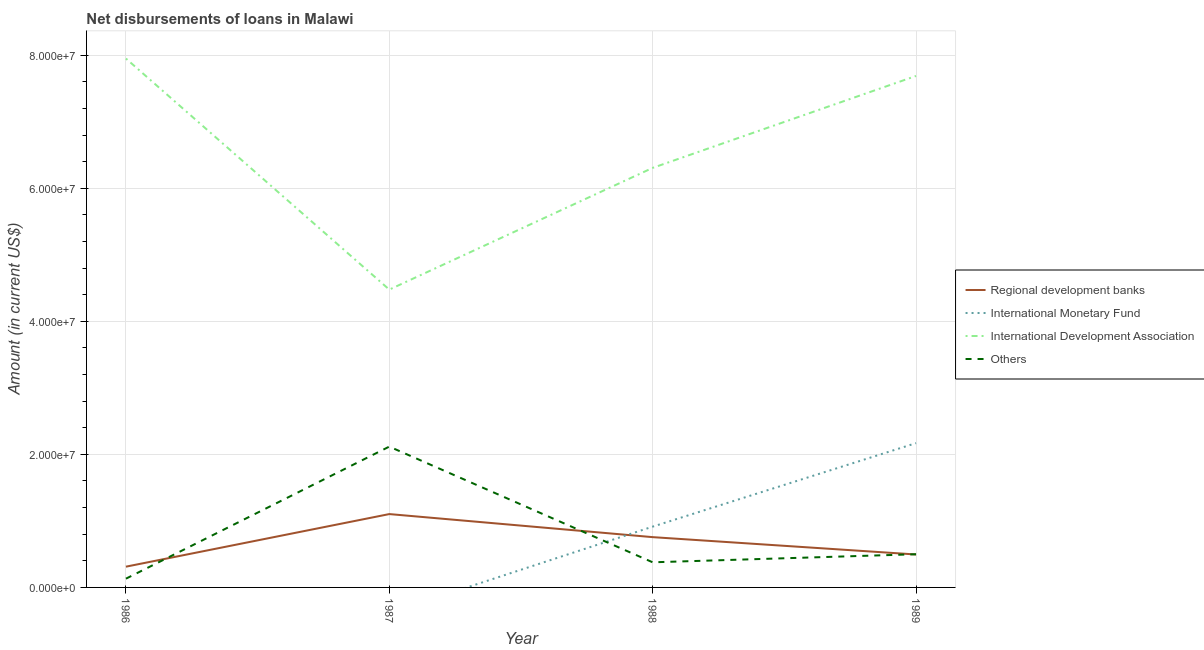Is the number of lines equal to the number of legend labels?
Your answer should be very brief. No. What is the amount of loan disimbursed by international development association in 1987?
Keep it short and to the point. 4.48e+07. Across all years, what is the maximum amount of loan disimbursed by international development association?
Ensure brevity in your answer.  7.95e+07. Across all years, what is the minimum amount of loan disimbursed by regional development banks?
Make the answer very short. 3.12e+06. In which year was the amount of loan disimbursed by international monetary fund maximum?
Offer a very short reply. 1989. What is the total amount of loan disimbursed by other organisations in the graph?
Your response must be concise. 3.13e+07. What is the difference between the amount of loan disimbursed by regional development banks in 1986 and that in 1989?
Your response must be concise. -1.83e+06. What is the difference between the amount of loan disimbursed by international monetary fund in 1989 and the amount of loan disimbursed by international development association in 1986?
Provide a short and direct response. -5.78e+07. What is the average amount of loan disimbursed by international monetary fund per year?
Ensure brevity in your answer.  7.71e+06. In the year 1988, what is the difference between the amount of loan disimbursed by other organisations and amount of loan disimbursed by international development association?
Give a very brief answer. -5.93e+07. What is the ratio of the amount of loan disimbursed by international development association in 1986 to that in 1989?
Give a very brief answer. 1.03. Is the amount of loan disimbursed by regional development banks in 1988 less than that in 1989?
Offer a terse response. No. What is the difference between the highest and the second highest amount of loan disimbursed by regional development banks?
Your response must be concise. 3.47e+06. What is the difference between the highest and the lowest amount of loan disimbursed by regional development banks?
Provide a succinct answer. 7.91e+06. In how many years, is the amount of loan disimbursed by international development association greater than the average amount of loan disimbursed by international development association taken over all years?
Your answer should be very brief. 2. Is it the case that in every year, the sum of the amount of loan disimbursed by regional development banks and amount of loan disimbursed by international monetary fund is greater than the sum of amount of loan disimbursed by other organisations and amount of loan disimbursed by international development association?
Offer a very short reply. No. Is it the case that in every year, the sum of the amount of loan disimbursed by regional development banks and amount of loan disimbursed by international monetary fund is greater than the amount of loan disimbursed by international development association?
Give a very brief answer. No. Is the amount of loan disimbursed by regional development banks strictly less than the amount of loan disimbursed by international development association over the years?
Make the answer very short. Yes. Does the graph contain grids?
Give a very brief answer. Yes. How many legend labels are there?
Your answer should be very brief. 4. What is the title of the graph?
Offer a terse response. Net disbursements of loans in Malawi. Does "United States" appear as one of the legend labels in the graph?
Offer a terse response. No. What is the label or title of the X-axis?
Give a very brief answer. Year. What is the label or title of the Y-axis?
Your answer should be compact. Amount (in current US$). What is the Amount (in current US$) in Regional development banks in 1986?
Your answer should be very brief. 3.12e+06. What is the Amount (in current US$) of International Monetary Fund in 1986?
Your answer should be very brief. 0. What is the Amount (in current US$) in International Development Association in 1986?
Provide a succinct answer. 7.95e+07. What is the Amount (in current US$) of Others in 1986?
Offer a terse response. 1.32e+06. What is the Amount (in current US$) in Regional development banks in 1987?
Keep it short and to the point. 1.10e+07. What is the Amount (in current US$) in International Development Association in 1987?
Ensure brevity in your answer.  4.48e+07. What is the Amount (in current US$) in Others in 1987?
Your answer should be compact. 2.12e+07. What is the Amount (in current US$) in Regional development banks in 1988?
Your answer should be very brief. 7.56e+06. What is the Amount (in current US$) in International Monetary Fund in 1988?
Give a very brief answer. 9.14e+06. What is the Amount (in current US$) in International Development Association in 1988?
Give a very brief answer. 6.31e+07. What is the Amount (in current US$) in Others in 1988?
Keep it short and to the point. 3.78e+06. What is the Amount (in current US$) of Regional development banks in 1989?
Provide a succinct answer. 4.95e+06. What is the Amount (in current US$) of International Monetary Fund in 1989?
Your answer should be very brief. 2.17e+07. What is the Amount (in current US$) of International Development Association in 1989?
Ensure brevity in your answer.  7.69e+07. What is the Amount (in current US$) in Others in 1989?
Your answer should be compact. 4.99e+06. Across all years, what is the maximum Amount (in current US$) in Regional development banks?
Offer a very short reply. 1.10e+07. Across all years, what is the maximum Amount (in current US$) in International Monetary Fund?
Your answer should be very brief. 2.17e+07. Across all years, what is the maximum Amount (in current US$) of International Development Association?
Your answer should be very brief. 7.95e+07. Across all years, what is the maximum Amount (in current US$) in Others?
Your answer should be very brief. 2.12e+07. Across all years, what is the minimum Amount (in current US$) in Regional development banks?
Offer a very short reply. 3.12e+06. Across all years, what is the minimum Amount (in current US$) in International Monetary Fund?
Your answer should be compact. 0. Across all years, what is the minimum Amount (in current US$) in International Development Association?
Your answer should be compact. 4.48e+07. Across all years, what is the minimum Amount (in current US$) of Others?
Keep it short and to the point. 1.32e+06. What is the total Amount (in current US$) of Regional development banks in the graph?
Keep it short and to the point. 2.67e+07. What is the total Amount (in current US$) in International Monetary Fund in the graph?
Your answer should be compact. 3.08e+07. What is the total Amount (in current US$) in International Development Association in the graph?
Your response must be concise. 2.64e+08. What is the total Amount (in current US$) of Others in the graph?
Offer a terse response. 3.13e+07. What is the difference between the Amount (in current US$) in Regional development banks in 1986 and that in 1987?
Your response must be concise. -7.91e+06. What is the difference between the Amount (in current US$) of International Development Association in 1986 and that in 1987?
Ensure brevity in your answer.  3.47e+07. What is the difference between the Amount (in current US$) of Others in 1986 and that in 1987?
Your answer should be very brief. -1.99e+07. What is the difference between the Amount (in current US$) of Regional development banks in 1986 and that in 1988?
Keep it short and to the point. -4.44e+06. What is the difference between the Amount (in current US$) in International Development Association in 1986 and that in 1988?
Give a very brief answer. 1.64e+07. What is the difference between the Amount (in current US$) of Others in 1986 and that in 1988?
Your answer should be very brief. -2.46e+06. What is the difference between the Amount (in current US$) of Regional development banks in 1986 and that in 1989?
Make the answer very short. -1.83e+06. What is the difference between the Amount (in current US$) of International Development Association in 1986 and that in 1989?
Your response must be concise. 2.62e+06. What is the difference between the Amount (in current US$) in Others in 1986 and that in 1989?
Provide a short and direct response. -3.67e+06. What is the difference between the Amount (in current US$) of Regional development banks in 1987 and that in 1988?
Give a very brief answer. 3.47e+06. What is the difference between the Amount (in current US$) of International Development Association in 1987 and that in 1988?
Your answer should be very brief. -1.83e+07. What is the difference between the Amount (in current US$) in Others in 1987 and that in 1988?
Give a very brief answer. 1.74e+07. What is the difference between the Amount (in current US$) in Regional development banks in 1987 and that in 1989?
Offer a terse response. 6.08e+06. What is the difference between the Amount (in current US$) in International Development Association in 1987 and that in 1989?
Your answer should be compact. -3.21e+07. What is the difference between the Amount (in current US$) in Others in 1987 and that in 1989?
Provide a short and direct response. 1.62e+07. What is the difference between the Amount (in current US$) of Regional development banks in 1988 and that in 1989?
Offer a terse response. 2.61e+06. What is the difference between the Amount (in current US$) of International Monetary Fund in 1988 and that in 1989?
Your answer should be very brief. -1.26e+07. What is the difference between the Amount (in current US$) in International Development Association in 1988 and that in 1989?
Offer a very short reply. -1.38e+07. What is the difference between the Amount (in current US$) of Others in 1988 and that in 1989?
Offer a very short reply. -1.21e+06. What is the difference between the Amount (in current US$) of Regional development banks in 1986 and the Amount (in current US$) of International Development Association in 1987?
Offer a terse response. -4.17e+07. What is the difference between the Amount (in current US$) in Regional development banks in 1986 and the Amount (in current US$) in Others in 1987?
Keep it short and to the point. -1.80e+07. What is the difference between the Amount (in current US$) of International Development Association in 1986 and the Amount (in current US$) of Others in 1987?
Your response must be concise. 5.83e+07. What is the difference between the Amount (in current US$) of Regional development banks in 1986 and the Amount (in current US$) of International Monetary Fund in 1988?
Your response must be concise. -6.02e+06. What is the difference between the Amount (in current US$) in Regional development banks in 1986 and the Amount (in current US$) in International Development Association in 1988?
Your answer should be very brief. -6.00e+07. What is the difference between the Amount (in current US$) in Regional development banks in 1986 and the Amount (in current US$) in Others in 1988?
Offer a very short reply. -6.57e+05. What is the difference between the Amount (in current US$) in International Development Association in 1986 and the Amount (in current US$) in Others in 1988?
Ensure brevity in your answer.  7.57e+07. What is the difference between the Amount (in current US$) of Regional development banks in 1986 and the Amount (in current US$) of International Monetary Fund in 1989?
Your response must be concise. -1.86e+07. What is the difference between the Amount (in current US$) of Regional development banks in 1986 and the Amount (in current US$) of International Development Association in 1989?
Your response must be concise. -7.38e+07. What is the difference between the Amount (in current US$) in Regional development banks in 1986 and the Amount (in current US$) in Others in 1989?
Ensure brevity in your answer.  -1.87e+06. What is the difference between the Amount (in current US$) of International Development Association in 1986 and the Amount (in current US$) of Others in 1989?
Give a very brief answer. 7.45e+07. What is the difference between the Amount (in current US$) of Regional development banks in 1987 and the Amount (in current US$) of International Monetary Fund in 1988?
Make the answer very short. 1.89e+06. What is the difference between the Amount (in current US$) in Regional development banks in 1987 and the Amount (in current US$) in International Development Association in 1988?
Provide a short and direct response. -5.20e+07. What is the difference between the Amount (in current US$) in Regional development banks in 1987 and the Amount (in current US$) in Others in 1988?
Ensure brevity in your answer.  7.25e+06. What is the difference between the Amount (in current US$) of International Development Association in 1987 and the Amount (in current US$) of Others in 1988?
Keep it short and to the point. 4.10e+07. What is the difference between the Amount (in current US$) in Regional development banks in 1987 and the Amount (in current US$) in International Monetary Fund in 1989?
Give a very brief answer. -1.07e+07. What is the difference between the Amount (in current US$) of Regional development banks in 1987 and the Amount (in current US$) of International Development Association in 1989?
Your answer should be compact. -6.59e+07. What is the difference between the Amount (in current US$) in Regional development banks in 1987 and the Amount (in current US$) in Others in 1989?
Offer a terse response. 6.04e+06. What is the difference between the Amount (in current US$) of International Development Association in 1987 and the Amount (in current US$) of Others in 1989?
Provide a succinct answer. 3.98e+07. What is the difference between the Amount (in current US$) in Regional development banks in 1988 and the Amount (in current US$) in International Monetary Fund in 1989?
Your response must be concise. -1.41e+07. What is the difference between the Amount (in current US$) in Regional development banks in 1988 and the Amount (in current US$) in International Development Association in 1989?
Give a very brief answer. -6.93e+07. What is the difference between the Amount (in current US$) of Regional development banks in 1988 and the Amount (in current US$) of Others in 1989?
Offer a terse response. 2.57e+06. What is the difference between the Amount (in current US$) in International Monetary Fund in 1988 and the Amount (in current US$) in International Development Association in 1989?
Your answer should be compact. -6.78e+07. What is the difference between the Amount (in current US$) of International Monetary Fund in 1988 and the Amount (in current US$) of Others in 1989?
Make the answer very short. 4.15e+06. What is the difference between the Amount (in current US$) of International Development Association in 1988 and the Amount (in current US$) of Others in 1989?
Your answer should be compact. 5.81e+07. What is the average Amount (in current US$) of Regional development banks per year?
Provide a short and direct response. 6.66e+06. What is the average Amount (in current US$) of International Monetary Fund per year?
Provide a succinct answer. 7.71e+06. What is the average Amount (in current US$) in International Development Association per year?
Your answer should be very brief. 6.61e+07. What is the average Amount (in current US$) in Others per year?
Your answer should be compact. 7.81e+06. In the year 1986, what is the difference between the Amount (in current US$) of Regional development banks and Amount (in current US$) of International Development Association?
Your answer should be very brief. -7.64e+07. In the year 1986, what is the difference between the Amount (in current US$) in Regional development banks and Amount (in current US$) in Others?
Keep it short and to the point. 1.80e+06. In the year 1986, what is the difference between the Amount (in current US$) in International Development Association and Amount (in current US$) in Others?
Give a very brief answer. 7.82e+07. In the year 1987, what is the difference between the Amount (in current US$) of Regional development banks and Amount (in current US$) of International Development Association?
Your response must be concise. -3.37e+07. In the year 1987, what is the difference between the Amount (in current US$) in Regional development banks and Amount (in current US$) in Others?
Ensure brevity in your answer.  -1.01e+07. In the year 1987, what is the difference between the Amount (in current US$) of International Development Association and Amount (in current US$) of Others?
Provide a short and direct response. 2.36e+07. In the year 1988, what is the difference between the Amount (in current US$) in Regional development banks and Amount (in current US$) in International Monetary Fund?
Your response must be concise. -1.58e+06. In the year 1988, what is the difference between the Amount (in current US$) of Regional development banks and Amount (in current US$) of International Development Association?
Give a very brief answer. -5.55e+07. In the year 1988, what is the difference between the Amount (in current US$) of Regional development banks and Amount (in current US$) of Others?
Provide a succinct answer. 3.78e+06. In the year 1988, what is the difference between the Amount (in current US$) in International Monetary Fund and Amount (in current US$) in International Development Association?
Provide a short and direct response. -5.39e+07. In the year 1988, what is the difference between the Amount (in current US$) of International Monetary Fund and Amount (in current US$) of Others?
Offer a very short reply. 5.36e+06. In the year 1988, what is the difference between the Amount (in current US$) of International Development Association and Amount (in current US$) of Others?
Offer a very short reply. 5.93e+07. In the year 1989, what is the difference between the Amount (in current US$) in Regional development banks and Amount (in current US$) in International Monetary Fund?
Ensure brevity in your answer.  -1.67e+07. In the year 1989, what is the difference between the Amount (in current US$) in Regional development banks and Amount (in current US$) in International Development Association?
Ensure brevity in your answer.  -7.19e+07. In the year 1989, what is the difference between the Amount (in current US$) in Regional development banks and Amount (in current US$) in Others?
Your response must be concise. -4.00e+04. In the year 1989, what is the difference between the Amount (in current US$) of International Monetary Fund and Amount (in current US$) of International Development Association?
Provide a short and direct response. -5.52e+07. In the year 1989, what is the difference between the Amount (in current US$) of International Monetary Fund and Amount (in current US$) of Others?
Provide a short and direct response. 1.67e+07. In the year 1989, what is the difference between the Amount (in current US$) in International Development Association and Amount (in current US$) in Others?
Offer a very short reply. 7.19e+07. What is the ratio of the Amount (in current US$) in Regional development banks in 1986 to that in 1987?
Offer a very short reply. 0.28. What is the ratio of the Amount (in current US$) in International Development Association in 1986 to that in 1987?
Provide a succinct answer. 1.78. What is the ratio of the Amount (in current US$) of Others in 1986 to that in 1987?
Give a very brief answer. 0.06. What is the ratio of the Amount (in current US$) in Regional development banks in 1986 to that in 1988?
Provide a short and direct response. 0.41. What is the ratio of the Amount (in current US$) in International Development Association in 1986 to that in 1988?
Offer a terse response. 1.26. What is the ratio of the Amount (in current US$) in Others in 1986 to that in 1988?
Provide a succinct answer. 0.35. What is the ratio of the Amount (in current US$) in Regional development banks in 1986 to that in 1989?
Provide a short and direct response. 0.63. What is the ratio of the Amount (in current US$) of International Development Association in 1986 to that in 1989?
Provide a succinct answer. 1.03. What is the ratio of the Amount (in current US$) of Others in 1986 to that in 1989?
Offer a very short reply. 0.26. What is the ratio of the Amount (in current US$) of Regional development banks in 1987 to that in 1988?
Your answer should be very brief. 1.46. What is the ratio of the Amount (in current US$) of International Development Association in 1987 to that in 1988?
Make the answer very short. 0.71. What is the ratio of the Amount (in current US$) in Others in 1987 to that in 1988?
Your answer should be compact. 5.61. What is the ratio of the Amount (in current US$) in Regional development banks in 1987 to that in 1989?
Keep it short and to the point. 2.23. What is the ratio of the Amount (in current US$) of International Development Association in 1987 to that in 1989?
Keep it short and to the point. 0.58. What is the ratio of the Amount (in current US$) of Others in 1987 to that in 1989?
Your response must be concise. 4.24. What is the ratio of the Amount (in current US$) in Regional development banks in 1988 to that in 1989?
Keep it short and to the point. 1.53. What is the ratio of the Amount (in current US$) in International Monetary Fund in 1988 to that in 1989?
Provide a succinct answer. 0.42. What is the ratio of the Amount (in current US$) of International Development Association in 1988 to that in 1989?
Your answer should be very brief. 0.82. What is the ratio of the Amount (in current US$) of Others in 1988 to that in 1989?
Provide a short and direct response. 0.76. What is the difference between the highest and the second highest Amount (in current US$) of Regional development banks?
Your answer should be compact. 3.47e+06. What is the difference between the highest and the second highest Amount (in current US$) of International Development Association?
Provide a short and direct response. 2.62e+06. What is the difference between the highest and the second highest Amount (in current US$) of Others?
Offer a very short reply. 1.62e+07. What is the difference between the highest and the lowest Amount (in current US$) of Regional development banks?
Give a very brief answer. 7.91e+06. What is the difference between the highest and the lowest Amount (in current US$) in International Monetary Fund?
Your answer should be compact. 2.17e+07. What is the difference between the highest and the lowest Amount (in current US$) in International Development Association?
Make the answer very short. 3.47e+07. What is the difference between the highest and the lowest Amount (in current US$) in Others?
Provide a short and direct response. 1.99e+07. 